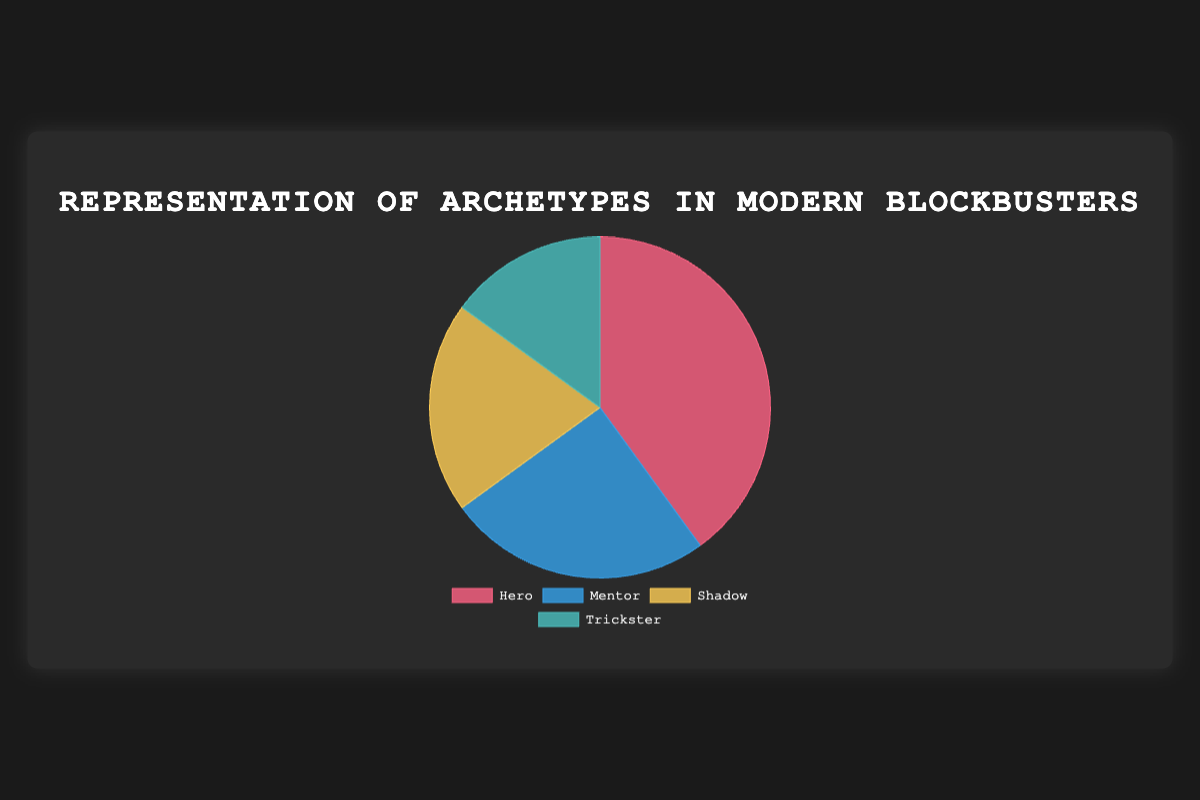What is the most represented archetype in modern blockbusters? The pie chart shows four archetypes with their respective percentages. The Hero archetype has the highest percentage at 40%.
Answer: Hero Which archetype is the least represented in modern blockbusters? Looking at the percentages in the pie chart, the Trickster archetype has the smallest percentage at 15%.
Answer: Trickster How much more represented is the Hero archetype compared to the Shadow archetype? The Hero archetype is represented at 40%, while the Shadow archetype is at 20%. The difference is 40% - 20% = 20%.
Answer: 20% What is the combined representation percentage of the Mentor and Trickster archetypes? Add the percentages of the Mentor and Trickster archetypes: 25% (Mentor) + 15% (Trickster) = 40%.
Answer: 40% Which two archetypes together represent exactly half of the total percentage? The Hero and Mentor archetypes together make up 40% (Hero) + 25% (Mentor) = 65%, while the Shadow and Trickster together make up 20% (Shadow) + 15% (Trickster) = 35%. No combination exactly equals 50%.
Answer: None Which colored section represents the Mentor archetype in the pie chart? The Mentor archetype is represented by the color blue as indicated in the chart legend.
Answer: Blue What is the average representation percentage of all four archetypes? To find the average, sum all the percentages and divide by the number of archetypes: (40% + 25% + 20% + 15%) = 100%, 100% / 4 = 25%.
Answer: 25% How does the representation of the Trickster archetype compare to the Mentor archetype? The Trickster archetype has a percentage of 15%, while the Mentor archetype has 25%. Thus, the Trickster has 10% less representation than the Mentor.
Answer: 10% less 